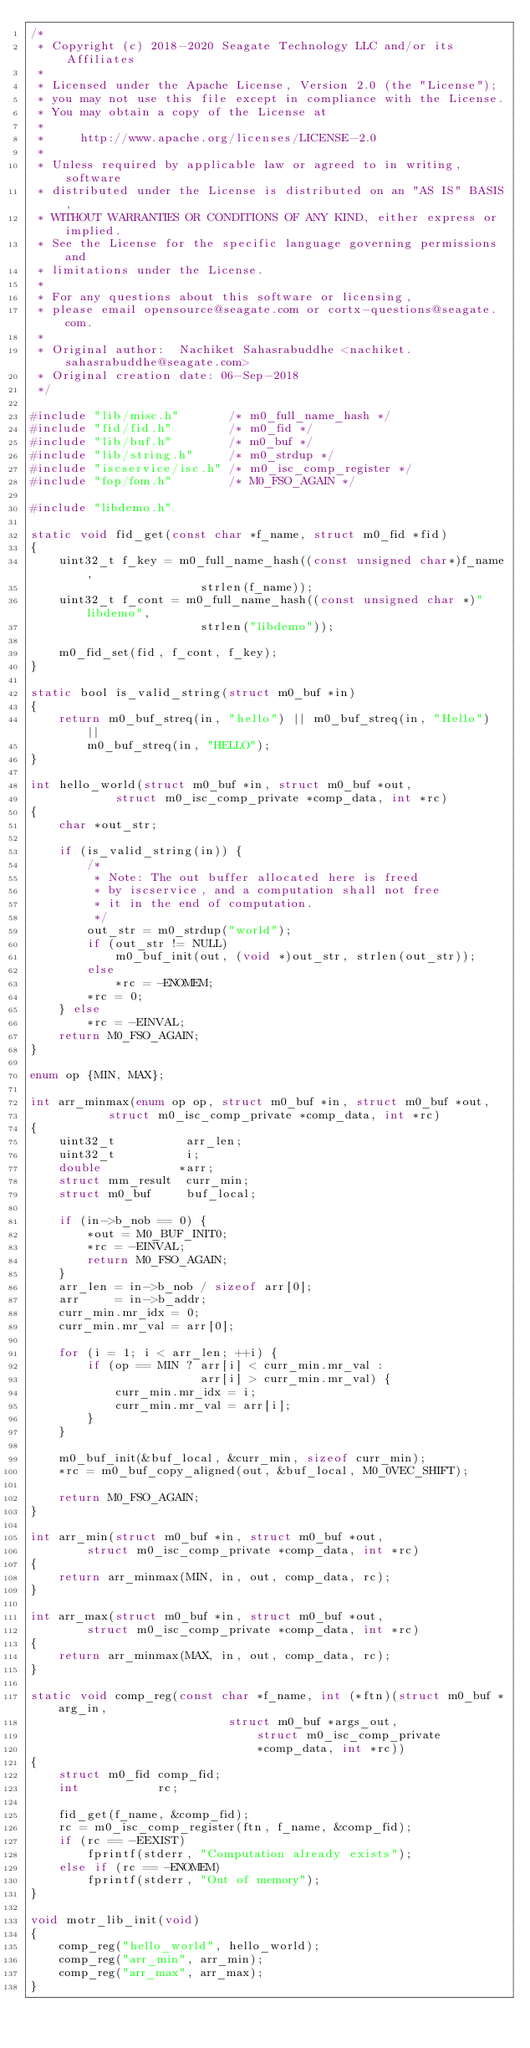<code> <loc_0><loc_0><loc_500><loc_500><_C_>/*
 * Copyright (c) 2018-2020 Seagate Technology LLC and/or its Affiliates
 *
 * Licensed under the Apache License, Version 2.0 (the "License");
 * you may not use this file except in compliance with the License.
 * You may obtain a copy of the License at
 *
 *     http://www.apache.org/licenses/LICENSE-2.0
 *
 * Unless required by applicable law or agreed to in writing, software
 * distributed under the License is distributed on an "AS IS" BASIS,
 * WITHOUT WARRANTIES OR CONDITIONS OF ANY KIND, either express or implied.
 * See the License for the specific language governing permissions and
 * limitations under the License.
 *
 * For any questions about this software or licensing,
 * please email opensource@seagate.com or cortx-questions@seagate.com.
 *
 * Original author:  Nachiket Sahasrabuddhe <nachiket.sahasrabuddhe@seagate.com>
 * Original creation date: 06-Sep-2018
 */

#include "lib/misc.h"       /* m0_full_name_hash */
#include "fid/fid.h"        /* m0_fid */
#include "lib/buf.h"        /* m0_buf */
#include "lib/string.h"     /* m0_strdup */
#include "iscservice/isc.h" /* m0_isc_comp_register */
#include "fop/fom.h"        /* M0_FSO_AGAIN */

#include "libdemo.h"

static void fid_get(const char *f_name, struct m0_fid *fid)
{
	uint32_t f_key = m0_full_name_hash((const unsigned char*)f_name,
					    strlen(f_name));
	uint32_t f_cont = m0_full_name_hash((const unsigned char *)"libdemo",
					    strlen("libdemo"));

	m0_fid_set(fid, f_cont, f_key);
}

static bool is_valid_string(struct m0_buf *in)
{
	return m0_buf_streq(in, "hello") || m0_buf_streq(in, "Hello") ||
		m0_buf_streq(in, "HELLO");
}

int hello_world(struct m0_buf *in, struct m0_buf *out,
	        struct m0_isc_comp_private *comp_data, int *rc)
{
	char *out_str;

	if (is_valid_string(in)) {
		/*
		 * Note: The out buffer allocated here is freed
		 * by iscservice, and a computation shall not free
		 * it in the end of computation.
		 */
		out_str = m0_strdup("world");
		if (out_str != NULL)
			m0_buf_init(out, (void *)out_str, strlen(out_str));
		else
			*rc = -ENOMEM;
		*rc = 0;
	} else
		*rc = -EINVAL;
	return M0_FSO_AGAIN;
}

enum op {MIN, MAX};

int arr_minmax(enum op op, struct m0_buf *in, struct m0_buf *out,
	       struct m0_isc_comp_private *comp_data, int *rc)
{
	uint32_t          arr_len;
	uint32_t          i;
	double           *arr;
	struct mm_result  curr_min;
	struct m0_buf     buf_local;

	if (in->b_nob == 0) {
		*out = M0_BUF_INIT0;
		*rc = -EINVAL;
		return M0_FSO_AGAIN;
	}
	arr_len = in->b_nob / sizeof arr[0];
	arr     = in->b_addr;
	curr_min.mr_idx = 0;
	curr_min.mr_val = arr[0];

	for (i = 1; i < arr_len; ++i) {
		if (op == MIN ? arr[i] < curr_min.mr_val :
		                arr[i] > curr_min.mr_val) {
			curr_min.mr_idx = i;
			curr_min.mr_val = arr[i];
		}
	}

	m0_buf_init(&buf_local, &curr_min, sizeof curr_min);
	*rc = m0_buf_copy_aligned(out, &buf_local, M0_0VEC_SHIFT);

	return M0_FSO_AGAIN;
}

int arr_min(struct m0_buf *in, struct m0_buf *out,
	    struct m0_isc_comp_private *comp_data, int *rc)
{
	return arr_minmax(MIN, in, out, comp_data, rc);
}

int arr_max(struct m0_buf *in, struct m0_buf *out,
	    struct m0_isc_comp_private *comp_data, int *rc)
{
	return arr_minmax(MAX, in, out, comp_data, rc);
}

static void comp_reg(const char *f_name, int (*ftn)(struct m0_buf *arg_in,
						    struct m0_buf *args_out,
					            struct m0_isc_comp_private
					            *comp_data, int *rc))
{
	struct m0_fid comp_fid;
	int           rc;

	fid_get(f_name, &comp_fid);
	rc = m0_isc_comp_register(ftn, f_name, &comp_fid);
	if (rc == -EEXIST)
		fprintf(stderr, "Computation already exists");
	else if (rc == -ENOMEM)
		fprintf(stderr, "Out of memory");
}

void motr_lib_init(void)
{
	comp_reg("hello_world", hello_world);
	comp_reg("arr_min", arr_min);
	comp_reg("arr_max", arr_max);
}
</code> 